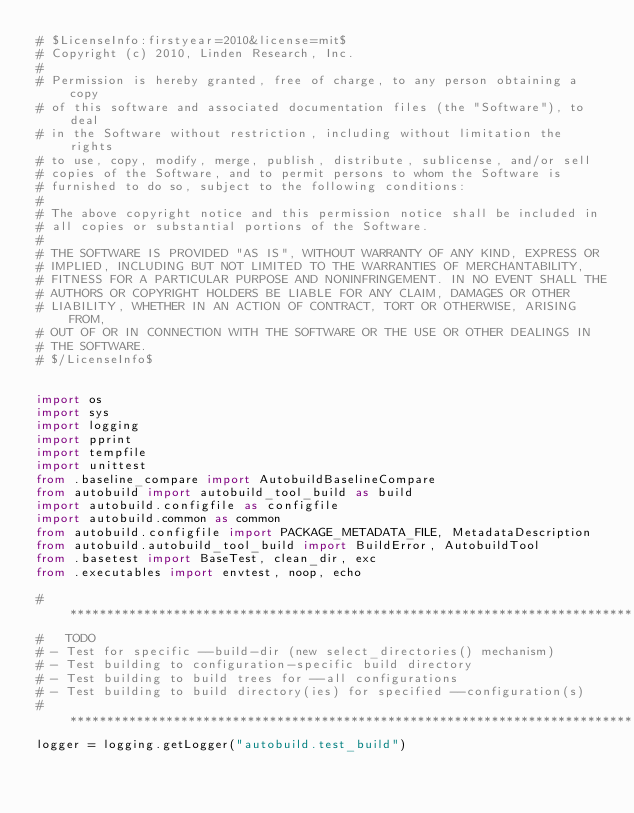Convert code to text. <code><loc_0><loc_0><loc_500><loc_500><_Python_># $LicenseInfo:firstyear=2010&license=mit$
# Copyright (c) 2010, Linden Research, Inc.
# 
# Permission is hereby granted, free of charge, to any person obtaining a copy
# of this software and associated documentation files (the "Software"), to deal
# in the Software without restriction, including without limitation the rights
# to use, copy, modify, merge, publish, distribute, sublicense, and/or sell
# copies of the Software, and to permit persons to whom the Software is
# furnished to do so, subject to the following conditions:
# 
# The above copyright notice and this permission notice shall be included in
# all copies or substantial portions of the Software.
# 
# THE SOFTWARE IS PROVIDED "AS IS", WITHOUT WARRANTY OF ANY KIND, EXPRESS OR
# IMPLIED, INCLUDING BUT NOT LIMITED TO THE WARRANTIES OF MERCHANTABILITY,
# FITNESS FOR A PARTICULAR PURPOSE AND NONINFRINGEMENT. IN NO EVENT SHALL THE
# AUTHORS OR COPYRIGHT HOLDERS BE LIABLE FOR ANY CLAIM, DAMAGES OR OTHER
# LIABILITY, WHETHER IN AN ACTION OF CONTRACT, TORT OR OTHERWISE, ARISING FROM,
# OUT OF OR IN CONNECTION WITH THE SOFTWARE OR THE USE OR OTHER DEALINGS IN
# THE SOFTWARE.
# $/LicenseInfo$


import os
import sys
import logging
import pprint
import tempfile
import unittest
from .baseline_compare import AutobuildBaselineCompare
from autobuild import autobuild_tool_build as build
import autobuild.configfile as configfile
import autobuild.common as common
from autobuild.configfile import PACKAGE_METADATA_FILE, MetadataDescription
from autobuild.autobuild_tool_build import BuildError, AutobuildTool
from .basetest import BaseTest, clean_dir, exc
from .executables import envtest, noop, echo

# ****************************************************************************
#   TODO
# - Test for specific --build-dir (new select_directories() mechanism)
# - Test building to configuration-specific build directory
# - Test building to build trees for --all configurations
# - Test building to build directory(ies) for specified --configuration(s)
# ****************************************************************************
logger = logging.getLogger("autobuild.test_build")
</code> 